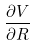Convert formula to latex. <formula><loc_0><loc_0><loc_500><loc_500>\frac { \partial V } { \partial R }</formula> 